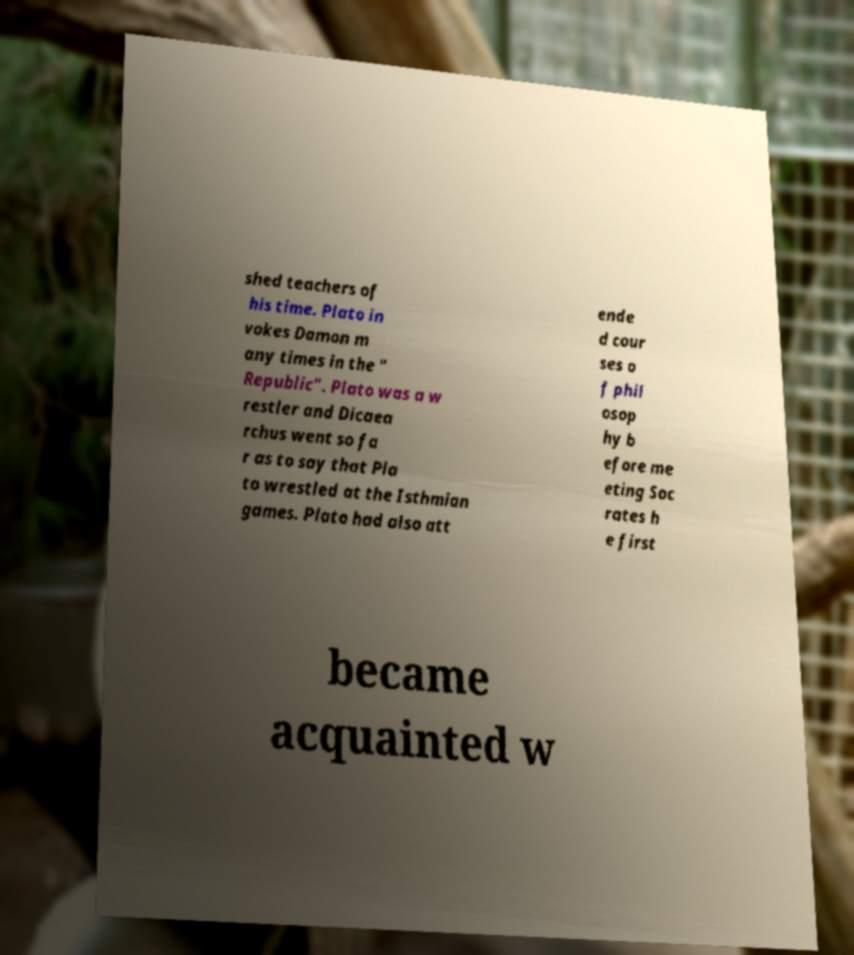Could you extract and type out the text from this image? shed teachers of his time. Plato in vokes Damon m any times in the " Republic". Plato was a w restler and Dicaea rchus went so fa r as to say that Pla to wrestled at the Isthmian games. Plato had also att ende d cour ses o f phil osop hy b efore me eting Soc rates h e first became acquainted w 